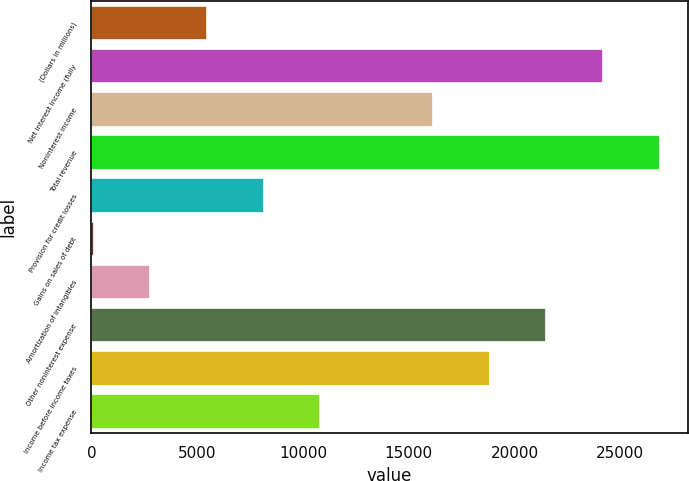Convert chart to OTSL. <chart><loc_0><loc_0><loc_500><loc_500><bar_chart><fcel>(Dollars in millions)<fcel>Net interest income (fully<fcel>Noninterest income<fcel>Total revenue<fcel>Provision for credit losses<fcel>Gains on sales of debt<fcel>Amortization of intangibles<fcel>Other noninterest expense<fcel>Income before income taxes<fcel>Income tax expense<nl><fcel>5465<fcel>24183<fcel>16161<fcel>26857<fcel>8139<fcel>117<fcel>2791<fcel>21509<fcel>18835<fcel>10813<nl></chart> 